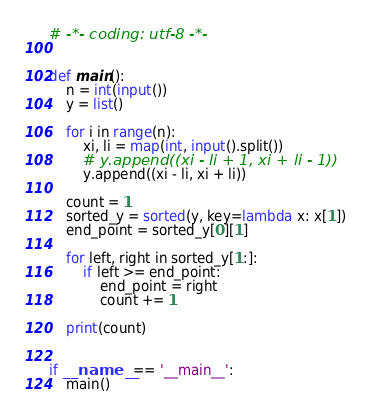Convert code to text. <code><loc_0><loc_0><loc_500><loc_500><_Python_># -*- coding: utf-8 -*-


def main():
    n = int(input())
    y = list()

    for i in range(n):
        xi, li = map(int, input().split())
        # y.append((xi - li + 1, xi + li - 1))
        y.append((xi - li, xi + li))

    count = 1
    sorted_y = sorted(y, key=lambda x: x[1])
    end_point = sorted_y[0][1]

    for left, right in sorted_y[1:]:
        if left >= end_point:
            end_point = right
            count += 1

    print(count)


if __name__ == '__main__':
    main()
</code> 